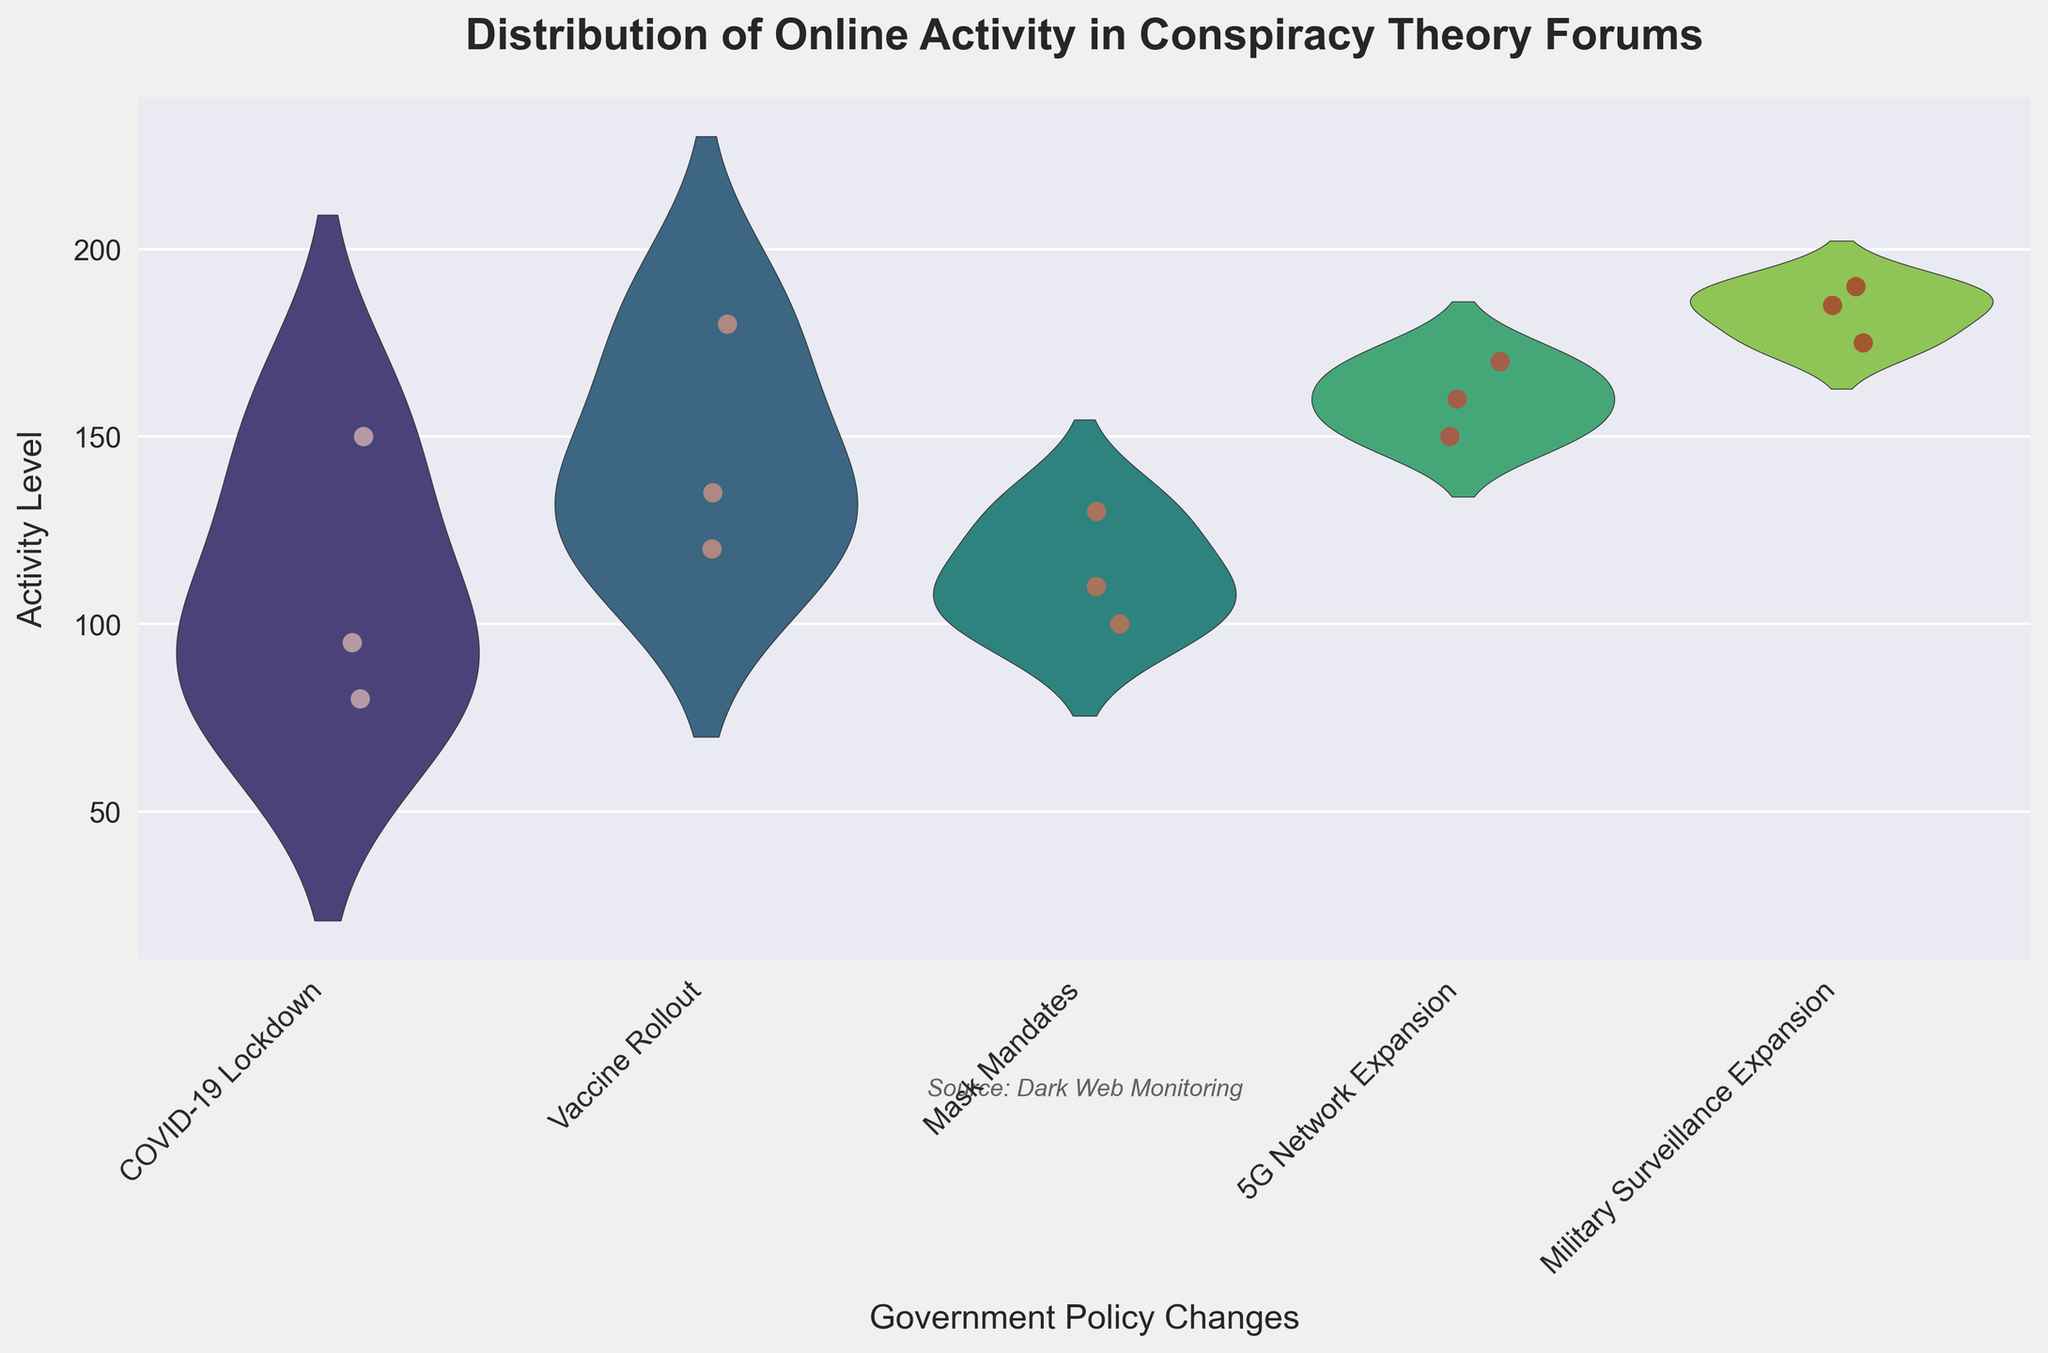What is the title of the plot? The title is the text at the top of the plot, which describes what the plot represents. In this case, the title is "Distribution of Online Activity in Conspiracy Theory Forums".
Answer: Distribution of Online Activity in Conspiracy Theory Forums Which policy change is associated with the highest activity level in the plot? To determine this, find the highest data point in the jittered points and see which policy change it aligns with. The highest point is for "Military Surveillance Expansion".
Answer: Military Surveillance Expansion What are the different colors used for the jittered points, and what do they represent? The jittered points use a red color gradient. The colors represent the individual data points within each policy change, shown with some transparency and jitter to differentiate them.
Answer: Red color gradient How does the activity level for "Mask Mandates" compare across the different forums? The activity levels for each forum given "Mask Mandates" can be identified and compared. AboveTopSecret has an activity level of 130, GodLikeProductions has 100, and TheBlackVault has 110, indicating "AboveTopSecret" has the highest while "GodLikeProductions" has the lowest levels.
Answer: AboveTopSecret (130), GodLikeProductions (100), TheBlackVault (110) What is the general trend in online activity as different policies were introduced? Look at the violin plots and jittered points to observe how activity levels change from one policy change to the next. Activity levels generally increase from "COVID-19 Lockdown" to "Military Surveillance Expansion".
Answer: Increasing trend Does "AboveTopSecret" always have the highest activity level for each policy change? To verify, check the jittered points associated with "AboveTopSecret" for each policy change. It can be seen that "AboveTopSecret" does not have the highest activity level for each policy change; for example, it doesn't have a higher activity level than "GodLikeProductions" during the "5G Network Expansion".
Answer: No Which policy change category shows the widest distribution of activity levels? The width of the violin plots indicates the distribution. The "Military Surveillance Expansion" policy change shows the widest distribution of activity levels.
Answer: Military Surveillance Expansion Which government policy change has the maximum variation in online activity? Maximum variation can be observed by examining the spread (width) of the violin plots. The "Military Surveillance Expansion" has the largest spread indicating the highest variation.
Answer: Military Surveillance Expansion What is the average activity level for "COVID-19 Lockdown"? The activity levels for "COVID-19 Lockdown" are 150, 80, and 95. To calculate the average: (150 + 80 + 95) / 3 = 325 / 3.
Answer: Approximately 108.33 Is there any policy change where all forums have similar activity levels? Check the jittered points for each forum under a specific policy change. The activity levels for "5G Network Expansion" are quite similar: AboveTopSecret has 170, GodLikeProductions has 150, and TheBlackVault has 160.
Answer: 5G Network Expansion 